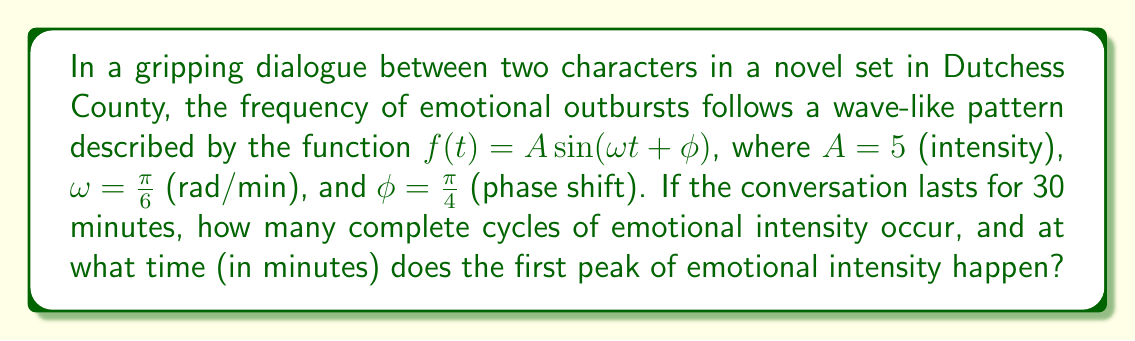Help me with this question. To solve this problem, we'll follow these steps:

1) First, let's calculate the number of complete cycles:
   The period of a sine wave is given by $T = \frac{2\pi}{\omega}$
   
   $T = \frac{2\pi}{\frac{\pi}{6}} = 12$ minutes

   The conversation lasts 30 minutes, so the number of complete cycles is:
   $\frac{30}{12} = 2.5$ cycles

2) Now, let's find the time of the first peak:
   The sine function reaches its first peak when its argument equals $\frac{\pi}{2}$
   
   So, we need to solve: $\omega t + \phi = \frac{\pi}{2}$
   
   $\frac{\pi}{6}t + \frac{\pi}{4} = \frac{\pi}{2}$
   
   $\frac{\pi}{6}t = \frac{\pi}{4}$
   
   $t = \frac{3}{2}$ minutes

Therefore, the dialogue completes 2 full cycles of emotional intensity, and the first peak occurs at 1.5 minutes into the conversation.
Answer: 2 cycles; 1.5 minutes 